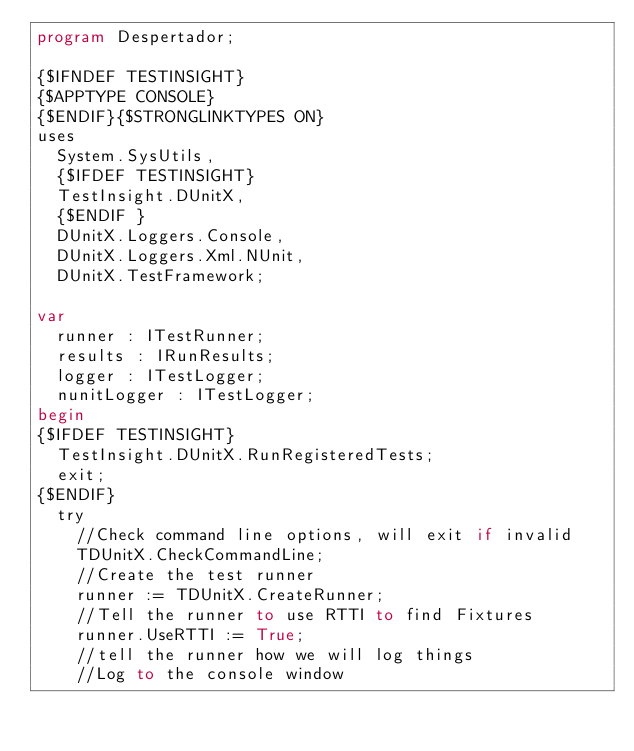<code> <loc_0><loc_0><loc_500><loc_500><_Pascal_>program Despertador;

{$IFNDEF TESTINSIGHT}
{$APPTYPE CONSOLE}
{$ENDIF}{$STRONGLINKTYPES ON}
uses
  System.SysUtils,
  {$IFDEF TESTINSIGHT}
  TestInsight.DUnitX,
  {$ENDIF }
  DUnitX.Loggers.Console,
  DUnitX.Loggers.Xml.NUnit,
  DUnitX.TestFramework;

var
  runner : ITestRunner;
  results : IRunResults;
  logger : ITestLogger;
  nunitLogger : ITestLogger;
begin
{$IFDEF TESTINSIGHT}
  TestInsight.DUnitX.RunRegisteredTests;
  exit;
{$ENDIF}
  try
    //Check command line options, will exit if invalid
    TDUnitX.CheckCommandLine;
    //Create the test runner
    runner := TDUnitX.CreateRunner;
    //Tell the runner to use RTTI to find Fixtures
    runner.UseRTTI := True;
    //tell the runner how we will log things
    //Log to the console window</code> 